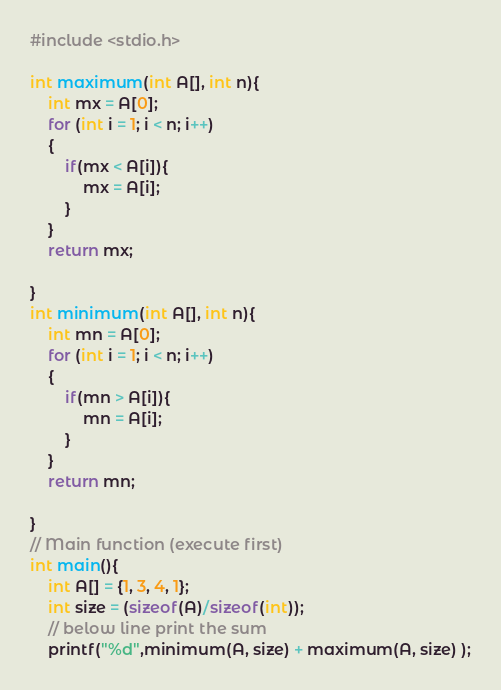Convert code to text. <code><loc_0><loc_0><loc_500><loc_500><_C_>#include <stdio.h>

int maximum(int A[], int n){
    int mx = A[0];
    for (int i = 1; i < n; i++)
    {
        if(mx < A[i]){
            mx = A[i];
        }
    }
    return mx;
    
}
int minimum(int A[], int n){
    int mn = A[0];
    for (int i = 1; i < n; i++)
    {
        if(mn > A[i]){
            mn = A[i];
        }
    }
    return mn;
    
}
// Main function (execute first)
int main(){
    int A[] = {1, 3, 4, 1}; 
    int size = (sizeof(A)/sizeof(int));
    // below line print the sum
    printf("%d",minimum(A, size) + maximum(A, size) );</code> 